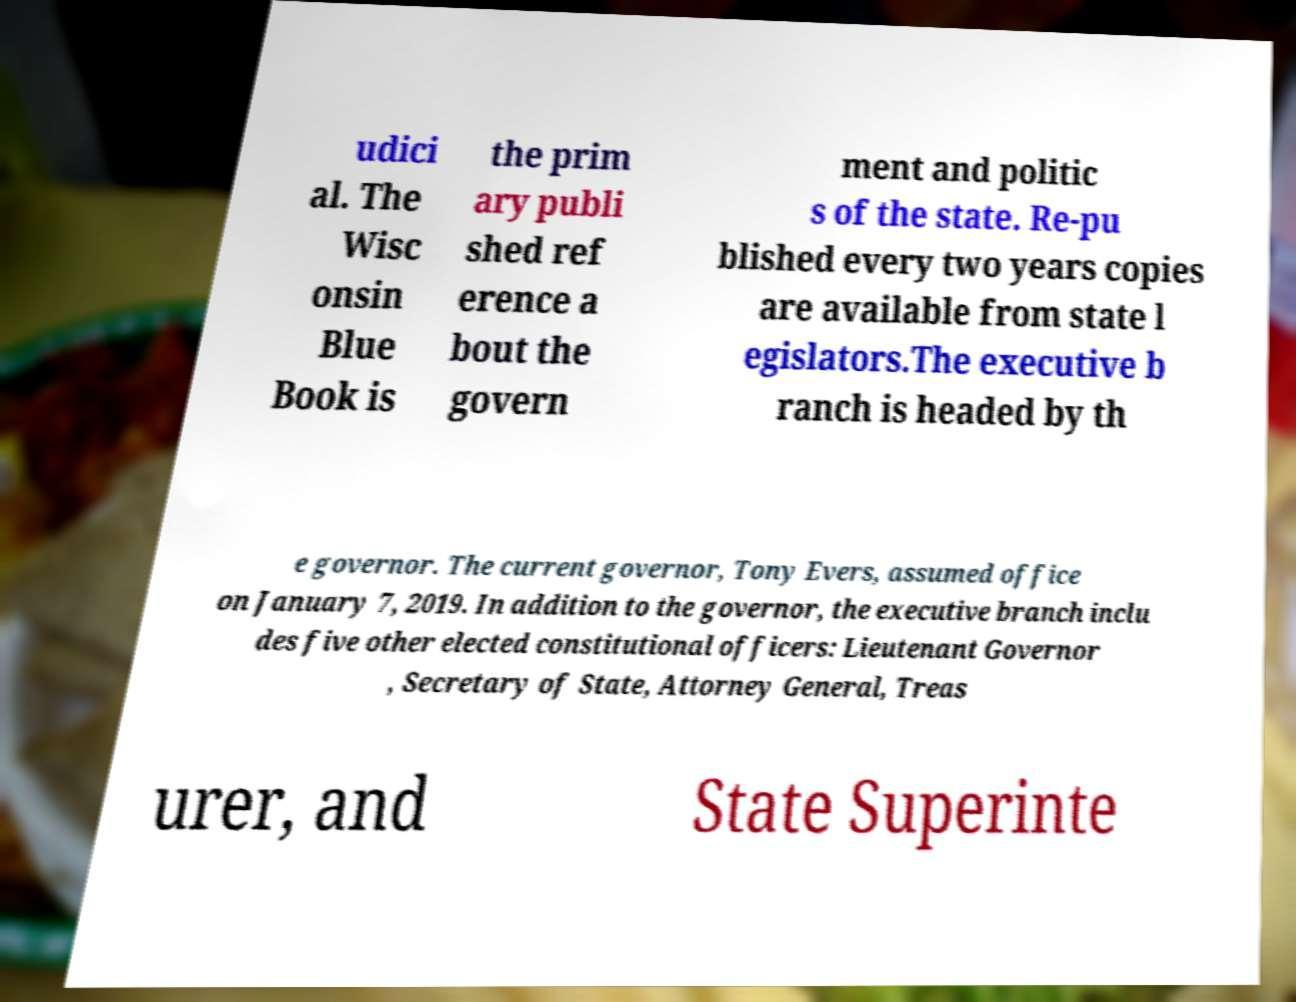For documentation purposes, I need the text within this image transcribed. Could you provide that? udici al. The Wisc onsin Blue Book is the prim ary publi shed ref erence a bout the govern ment and politic s of the state. Re-pu blished every two years copies are available from state l egislators.The executive b ranch is headed by th e governor. The current governor, Tony Evers, assumed office on January 7, 2019. In addition to the governor, the executive branch inclu des five other elected constitutional officers: Lieutenant Governor , Secretary of State, Attorney General, Treas urer, and State Superinte 